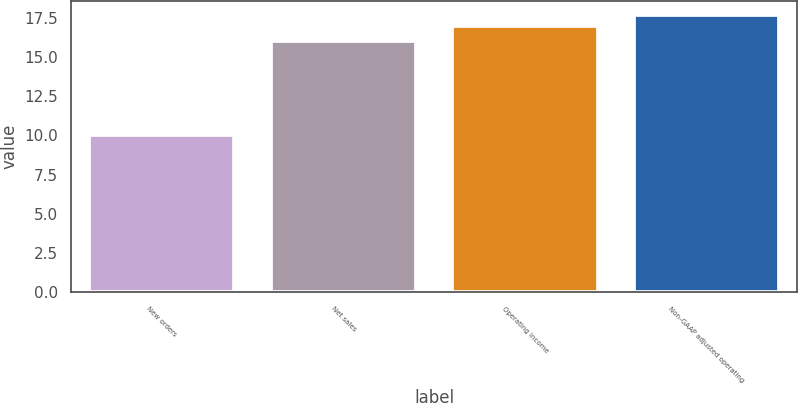Convert chart. <chart><loc_0><loc_0><loc_500><loc_500><bar_chart><fcel>New orders<fcel>Net sales<fcel>Operating income<fcel>Non-GAAP adjusted operating<nl><fcel>10<fcel>16<fcel>17<fcel>17.7<nl></chart> 